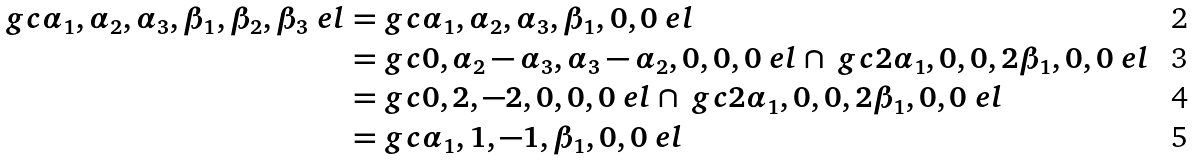<formula> <loc_0><loc_0><loc_500><loc_500>\ g c { \alpha _ { 1 } , \alpha _ { 2 } , \alpha _ { 3 } , \beta _ { 1 } , \beta _ { 2 } , \beta _ { 3 } } \ e l = & \ g c { \alpha _ { 1 } , \alpha _ { 2 } , \alpha _ { 3 } , \beta _ { 1 } , 0 , 0 } \ e l \\ = & \ g c { 0 , \alpha _ { 2 } - \alpha _ { 3 } , \alpha _ { 3 } - \alpha _ { 2 } , 0 , 0 , 0 } \ e l \cap \ g c { 2 \alpha _ { 1 } , 0 , 0 , 2 \beta _ { 1 } , 0 , 0 } \ e l \\ = & \ g c { 0 , 2 , - 2 , 0 , 0 , 0 } \ e l \cap \ g c { 2 \alpha _ { 1 } , 0 , 0 , 2 \beta _ { 1 } , 0 , 0 } \ e l \\ = & \ g c { \alpha _ { 1 } , 1 , - 1 , \beta _ { 1 } , 0 , 0 } \ e l</formula> 